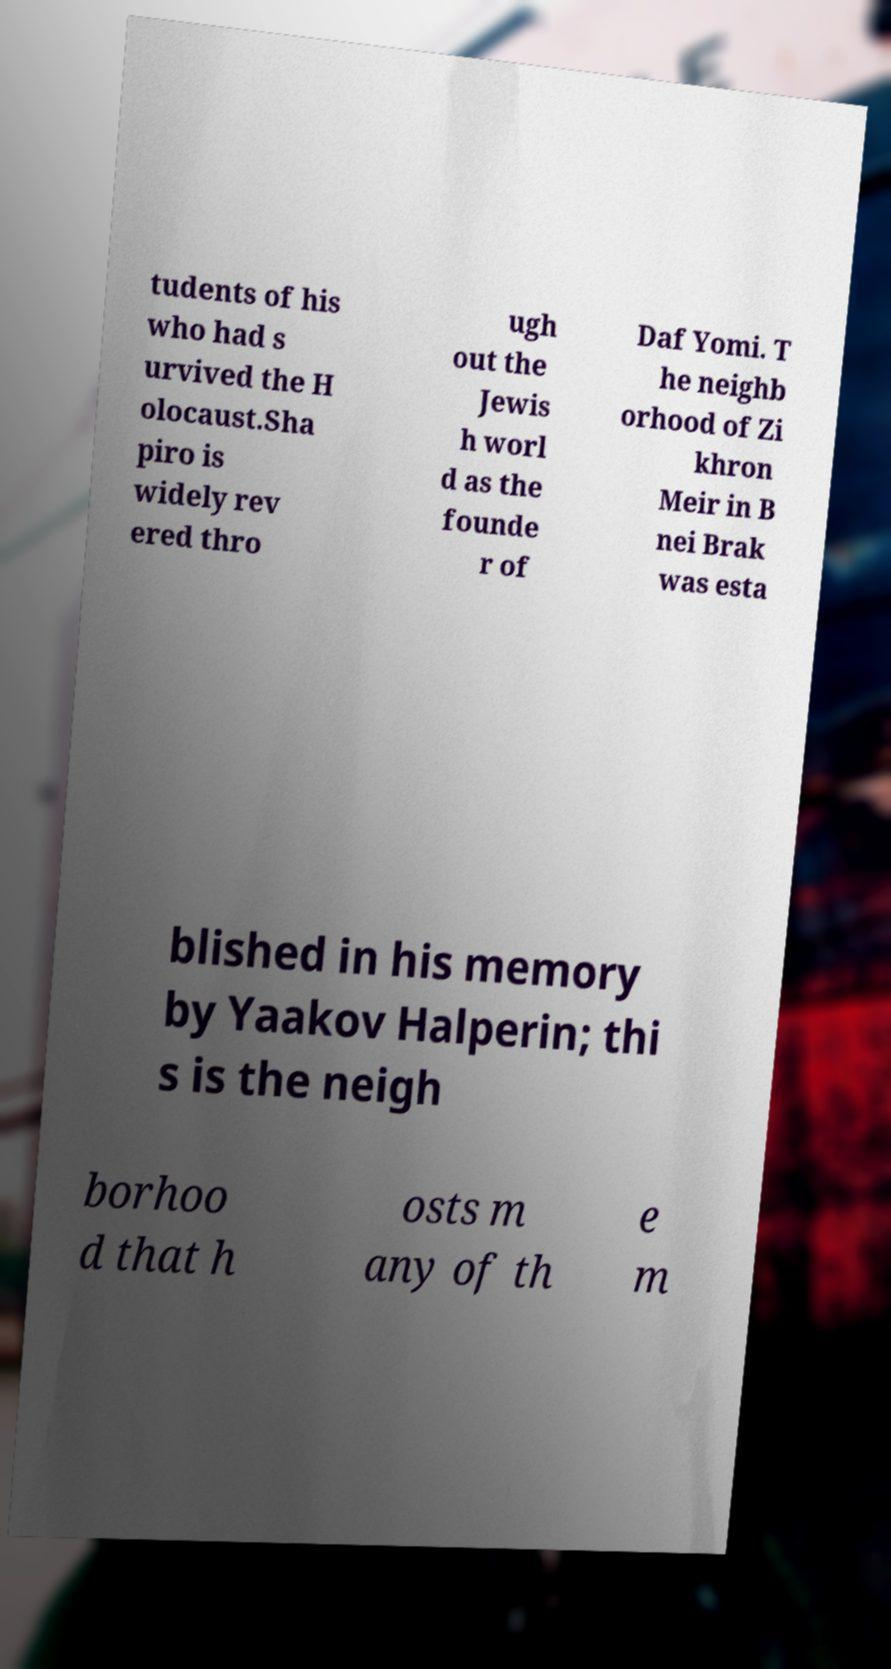Could you extract and type out the text from this image? tudents of his who had s urvived the H olocaust.Sha piro is widely rev ered thro ugh out the Jewis h worl d as the founde r of Daf Yomi. T he neighb orhood of Zi khron Meir in B nei Brak was esta blished in his memory by Yaakov Halperin; thi s is the neigh borhoo d that h osts m any of th e m 